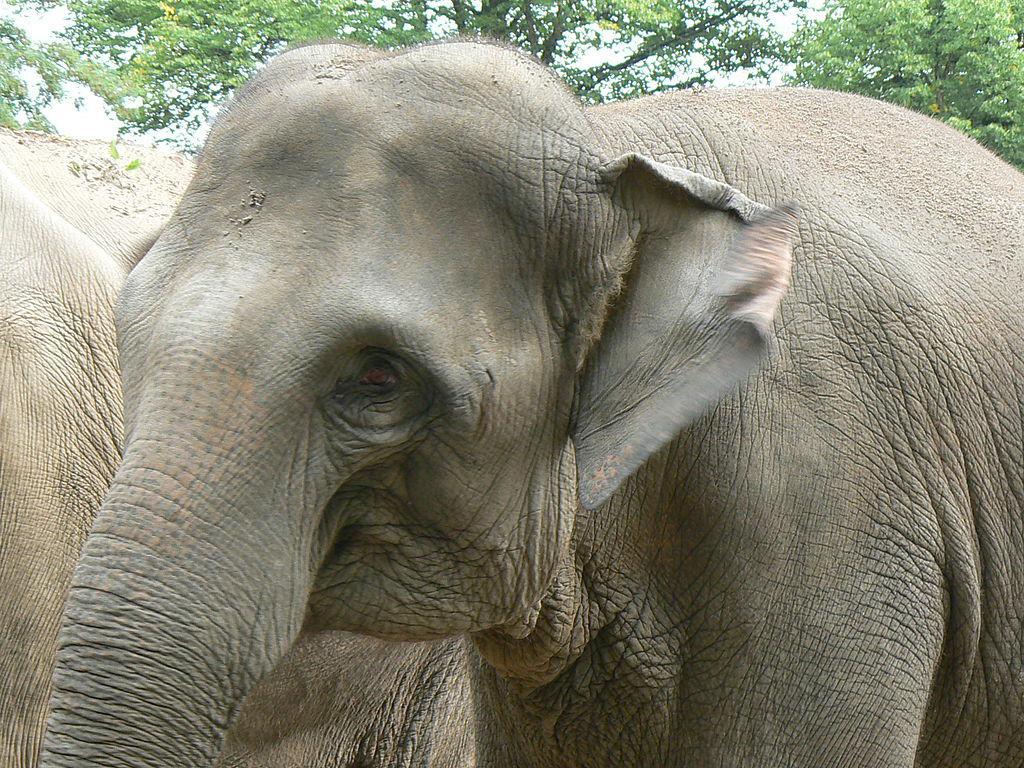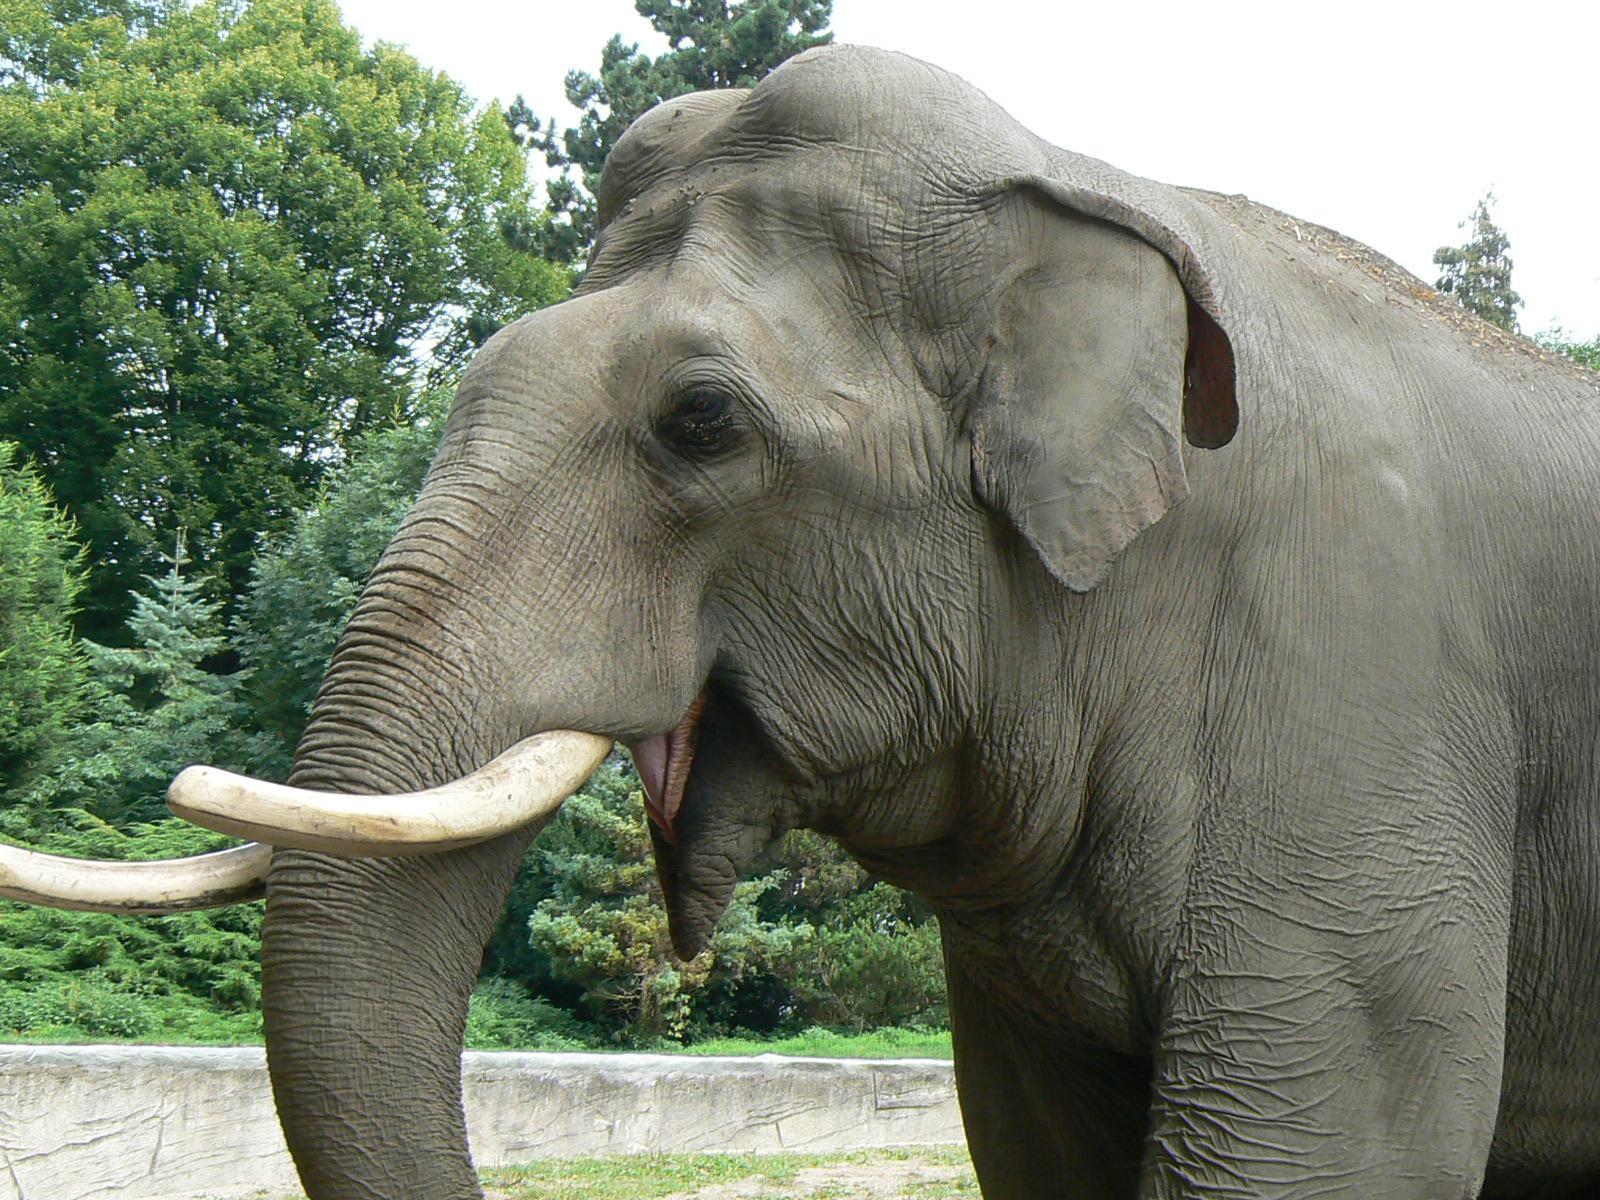The first image is the image on the left, the second image is the image on the right. Evaluate the accuracy of this statement regarding the images: "Both elephants are facing towards the left.". Is it true? Answer yes or no. Yes. The first image is the image on the left, the second image is the image on the right. Assess this claim about the two images: "The elephant in the image on the right has its feet on a man made structure.". Correct or not? Answer yes or no. No. 